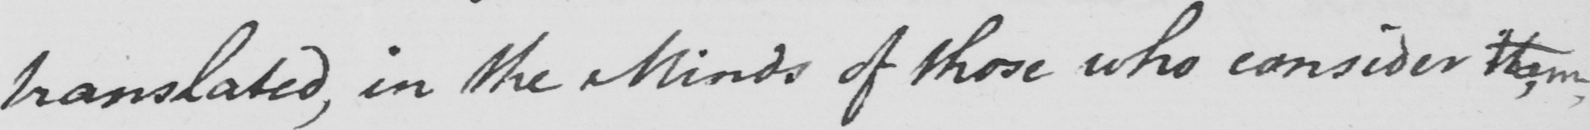Please transcribe the handwritten text in this image. translated , in the Minds of those who consider them , 